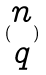Convert formula to latex. <formula><loc_0><loc_0><loc_500><loc_500>( \begin{matrix} n \\ q \end{matrix} )</formula> 